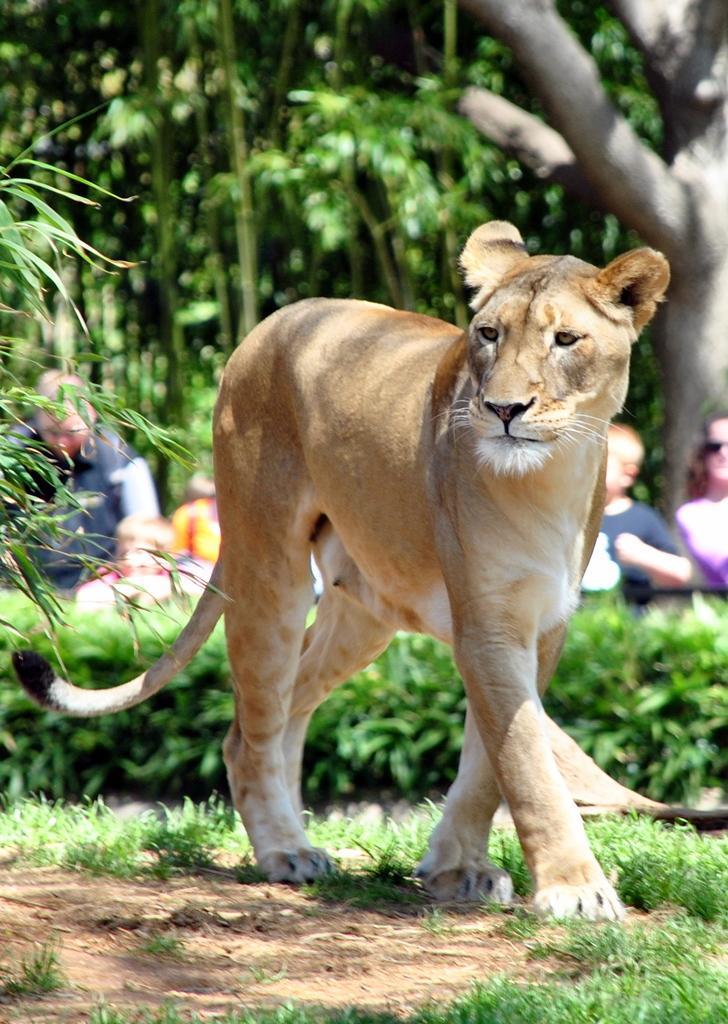Could you give a brief overview of what you see in this image? In this image there is a tiger in the middle. In the background there are trees. On the ground there is grass and sand. In the background there are few kids standing on the ground and watching the tiger. 